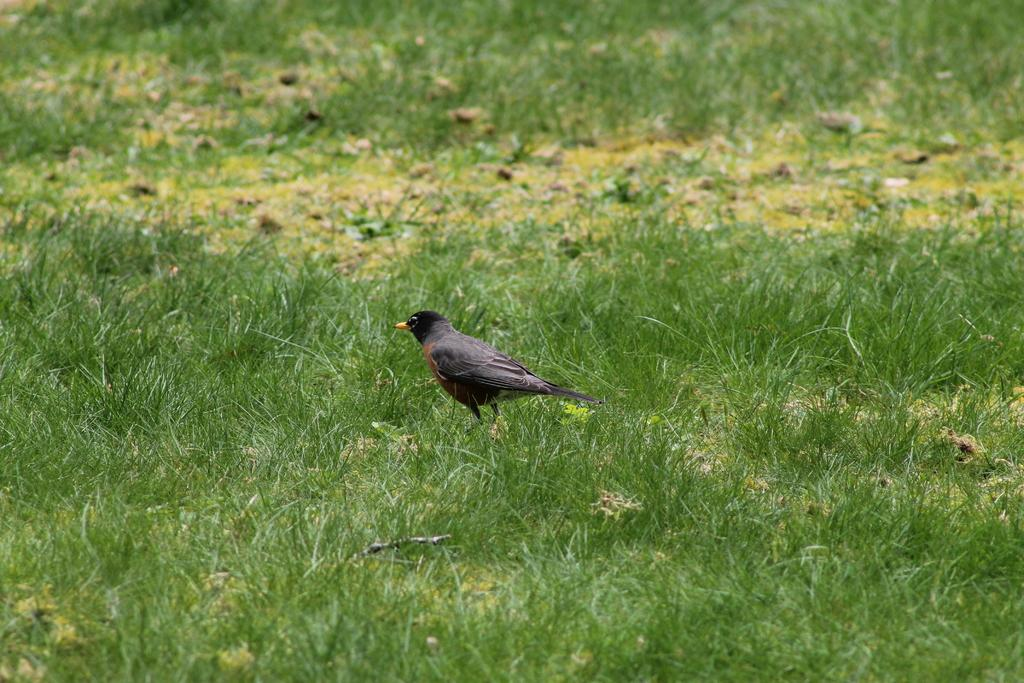What type of animal is in the image? There is a bird in the image. Where is the bird located? The bird is on the grass. What is the grass situated on? The grass is on the ground. What type of clock can be seen on the boat in the image? There is no clock or boat present in the image; it features a bird on the grass. 